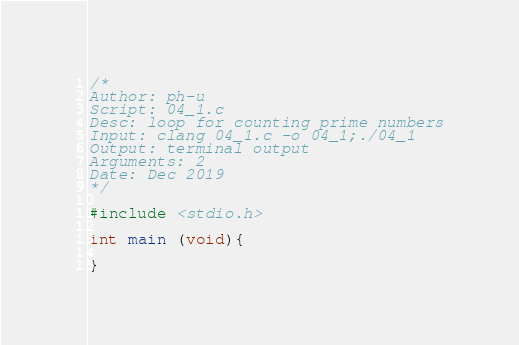Convert code to text. <code><loc_0><loc_0><loc_500><loc_500><_C_>/* 
Author: ph-u
Script: 04_1.c
Desc: loop for counting prime numbers
Input: clang 04_1.c -o 04_1;./04_1
Output: terminal output
Arguments: 2
Date: Dec 2019
*/

#include <stdio.h>

int main (void){

}
</code> 